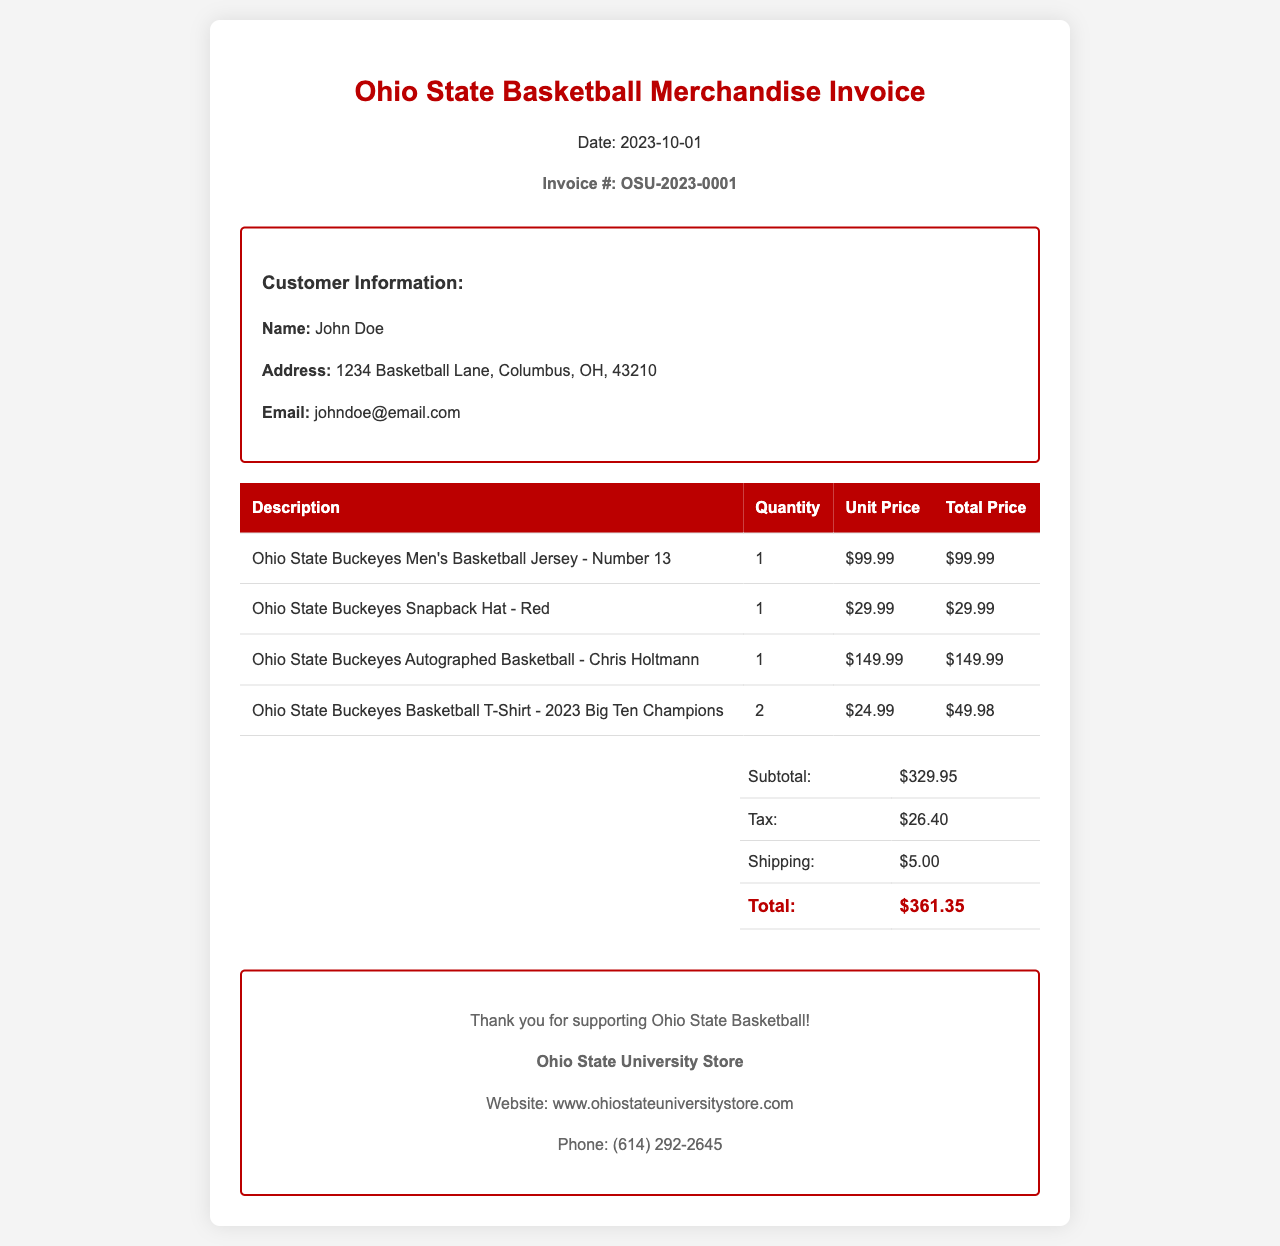What is the invoice number? The invoice number is displayed prominently in the document with the format "OSU-XXXX-XXXX".
Answer: OSU-2023-0001 What is the total amount due? The total amount due is calculated based on subtotal, tax, and shipping costs presented in the summary section.
Answer: $361.35 Who is the customer? The customer information includes their name, which is listed in the document.
Answer: John Doe What date is the invoice dated? The date of the invoice is mentioned below the title in a specific format.
Answer: 2023-10-01 How many Ohio State Basketball T-Shirts were purchased? The quantity of the t-shirts is listed in the respective row under the quantity column in the table.
Answer: 2 What is the subtotal amount before tax and shipping? The subtotal is the total of all merchandise prices listed before adding tax and shipping.
Answer: $329.95 What is the shipping cost? The shipping cost is shown in the summary section along with other financial details.
Answer: $5.00 Which item is autographed? The specific item is noted in its description in the merchandise table.
Answer: Chris Holtmann What website can be visited for more merchandise? The website information is provided in the footer section of the invoice.
Answer: www.ohiostateuniversitystore.com 